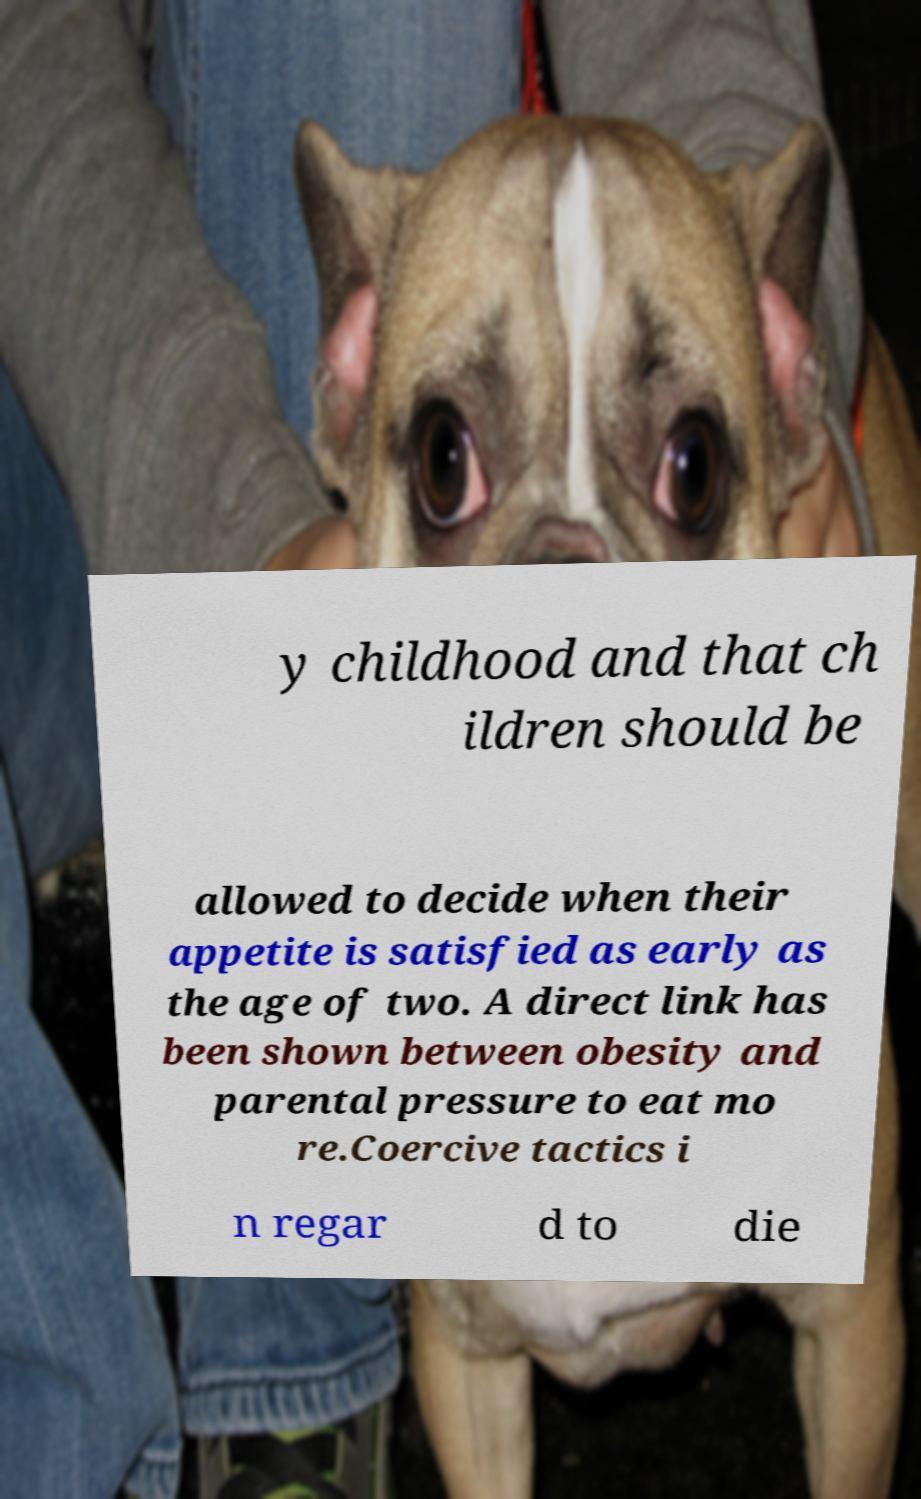For documentation purposes, I need the text within this image transcribed. Could you provide that? y childhood and that ch ildren should be allowed to decide when their appetite is satisfied as early as the age of two. A direct link has been shown between obesity and parental pressure to eat mo re.Coercive tactics i n regar d to die 